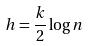<formula> <loc_0><loc_0><loc_500><loc_500>h = \frac { k } { 2 } \log n</formula> 